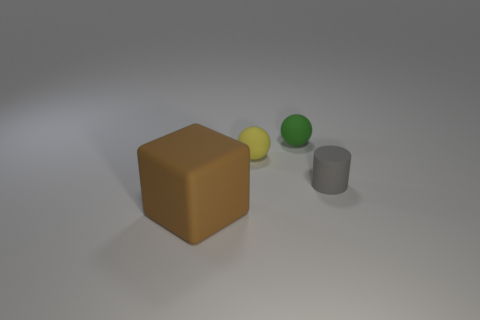Subtract all green balls. How many balls are left? 1 Add 1 large brown matte objects. How many objects exist? 5 Subtract 1 balls. How many balls are left? 1 Subtract all cylinders. How many objects are left? 3 Subtract all gray cylinders. How many yellow cubes are left? 0 Add 4 tiny gray matte things. How many tiny gray matte things are left? 5 Add 1 large purple rubber things. How many large purple rubber things exist? 1 Subtract 1 gray cylinders. How many objects are left? 3 Subtract all purple spheres. Subtract all green blocks. How many spheres are left? 2 Subtract all big metal things. Subtract all large brown objects. How many objects are left? 3 